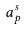Convert formula to latex. <formula><loc_0><loc_0><loc_500><loc_500>a _ { p } ^ { s }</formula> 